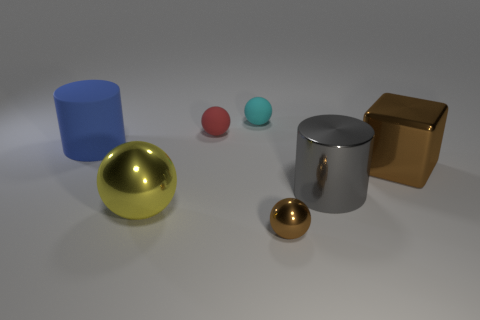Do the big blue cylinder and the tiny red thing have the same material?
Ensure brevity in your answer.  Yes. What shape is the big gray object that is made of the same material as the small brown thing?
Give a very brief answer. Cylinder. Do the cylinder behind the gray metal thing and the small metallic ball have the same size?
Your answer should be very brief. No. Is the number of large blue rubber cylinders in front of the shiny cylinder greater than the number of big brown matte balls?
Offer a very short reply. No. How many yellow metal spheres are behind the cylinder that is left of the yellow metallic object?
Offer a very short reply. 0. Is the number of tiny cyan rubber objects that are on the right side of the small brown ball less than the number of big gray metallic cylinders?
Keep it short and to the point. Yes. There is a big sphere behind the brown shiny object that is in front of the brown cube; are there any large blue matte things that are in front of it?
Make the answer very short. No. Is the material of the big brown block the same as the cyan thing that is behind the large blue matte cylinder?
Give a very brief answer. No. There is a cylinder that is left of the brown thing to the left of the large gray shiny object; what is its color?
Give a very brief answer. Blue. Are there any tiny rubber spheres of the same color as the tiny metal ball?
Provide a short and direct response. No. 